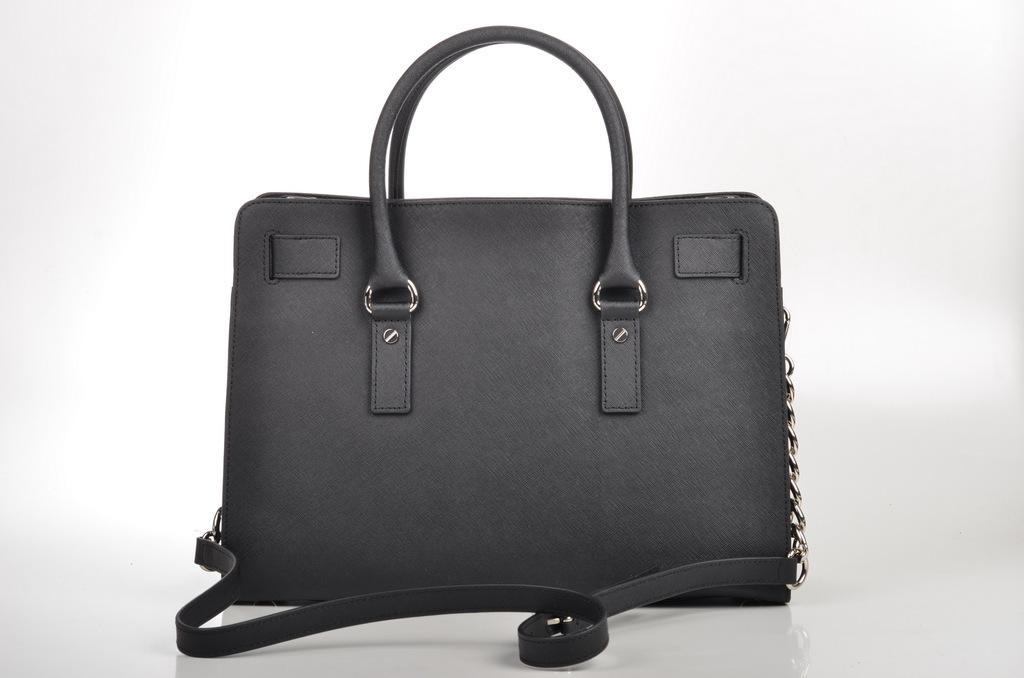Could you give a brief overview of what you see in this image? In this picture there is a beautifully designed bag and to the right side of it there is a chain attached to it. 